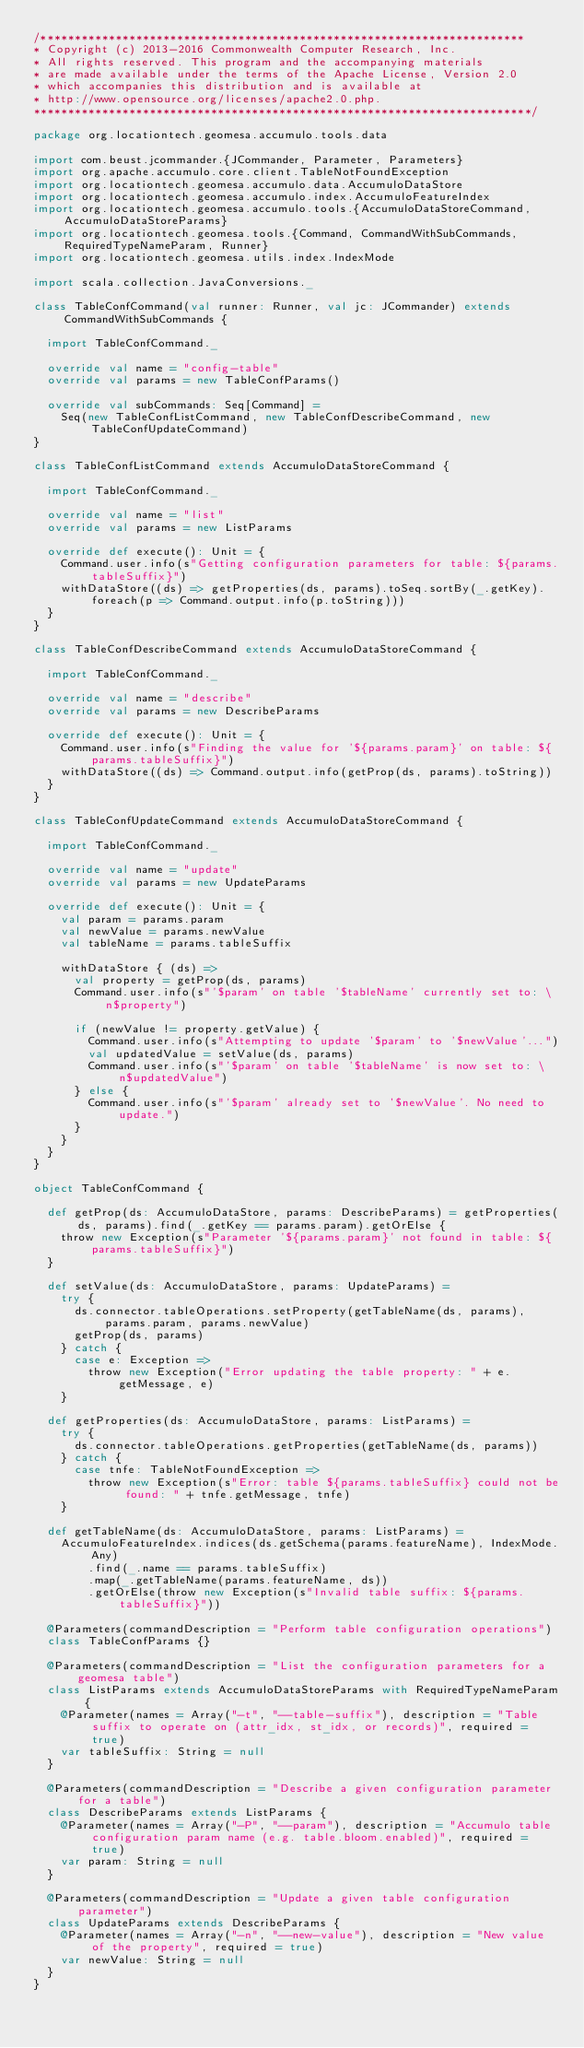<code> <loc_0><loc_0><loc_500><loc_500><_Scala_>/***********************************************************************
* Copyright (c) 2013-2016 Commonwealth Computer Research, Inc.
* All rights reserved. This program and the accompanying materials
* are made available under the terms of the Apache License, Version 2.0
* which accompanies this distribution and is available at
* http://www.opensource.org/licenses/apache2.0.php.
*************************************************************************/

package org.locationtech.geomesa.accumulo.tools.data

import com.beust.jcommander.{JCommander, Parameter, Parameters}
import org.apache.accumulo.core.client.TableNotFoundException
import org.locationtech.geomesa.accumulo.data.AccumuloDataStore
import org.locationtech.geomesa.accumulo.index.AccumuloFeatureIndex
import org.locationtech.geomesa.accumulo.tools.{AccumuloDataStoreCommand, AccumuloDataStoreParams}
import org.locationtech.geomesa.tools.{Command, CommandWithSubCommands, RequiredTypeNameParam, Runner}
import org.locationtech.geomesa.utils.index.IndexMode

import scala.collection.JavaConversions._

class TableConfCommand(val runner: Runner, val jc: JCommander) extends CommandWithSubCommands {

  import TableConfCommand._

  override val name = "config-table"
  override val params = new TableConfParams()

  override val subCommands: Seq[Command] =
    Seq(new TableConfListCommand, new TableConfDescribeCommand, new TableConfUpdateCommand)
}

class TableConfListCommand extends AccumuloDataStoreCommand {

  import TableConfCommand._

  override val name = "list"
  override val params = new ListParams

  override def execute(): Unit = {
    Command.user.info(s"Getting configuration parameters for table: ${params.tableSuffix}")
    withDataStore((ds) => getProperties(ds, params).toSeq.sortBy(_.getKey).foreach(p => Command.output.info(p.toString)))
  }
}

class TableConfDescribeCommand extends AccumuloDataStoreCommand {

  import TableConfCommand._

  override val name = "describe"
  override val params = new DescribeParams

  override def execute(): Unit = {
    Command.user.info(s"Finding the value for '${params.param}' on table: ${params.tableSuffix}")
    withDataStore((ds) => Command.output.info(getProp(ds, params).toString))
  }
}

class TableConfUpdateCommand extends AccumuloDataStoreCommand {

  import TableConfCommand._

  override val name = "update"
  override val params = new UpdateParams

  override def execute(): Unit = {
    val param = params.param
    val newValue = params.newValue
    val tableName = params.tableSuffix

    withDataStore { (ds) =>
      val property = getProp(ds, params)
      Command.user.info(s"'$param' on table '$tableName' currently set to: \n$property")

      if (newValue != property.getValue) {
        Command.user.info(s"Attempting to update '$param' to '$newValue'...")
        val updatedValue = setValue(ds, params)
        Command.user.info(s"'$param' on table '$tableName' is now set to: \n$updatedValue")
      } else {
        Command.user.info(s"'$param' already set to '$newValue'. No need to update.")
      }
    }
  }
}

object TableConfCommand {

  def getProp(ds: AccumuloDataStore, params: DescribeParams) = getProperties(ds, params).find(_.getKey == params.param).getOrElse {
    throw new Exception(s"Parameter '${params.param}' not found in table: ${params.tableSuffix}")
  }

  def setValue(ds: AccumuloDataStore, params: UpdateParams) =
    try {
      ds.connector.tableOperations.setProperty(getTableName(ds, params), params.param, params.newValue)
      getProp(ds, params)
    } catch {
      case e: Exception =>
        throw new Exception("Error updating the table property: " + e.getMessage, e)
    }

  def getProperties(ds: AccumuloDataStore, params: ListParams) =
    try {
      ds.connector.tableOperations.getProperties(getTableName(ds, params))
    } catch {
      case tnfe: TableNotFoundException =>
        throw new Exception(s"Error: table ${params.tableSuffix} could not be found: " + tnfe.getMessage, tnfe)
    }
  
  def getTableName(ds: AccumuloDataStore, params: ListParams) =
    AccumuloFeatureIndex.indices(ds.getSchema(params.featureName), IndexMode.Any)
        .find(_.name == params.tableSuffix)
        .map(_.getTableName(params.featureName, ds))
        .getOrElse(throw new Exception(s"Invalid table suffix: ${params.tableSuffix}"))
  
  @Parameters(commandDescription = "Perform table configuration operations")
  class TableConfParams {}

  @Parameters(commandDescription = "List the configuration parameters for a geomesa table")
  class ListParams extends AccumuloDataStoreParams with RequiredTypeNameParam {
    @Parameter(names = Array("-t", "--table-suffix"), description = "Table suffix to operate on (attr_idx, st_idx, or records)", required = true)
    var tableSuffix: String = null
  }

  @Parameters(commandDescription = "Describe a given configuration parameter for a table")
  class DescribeParams extends ListParams {
    @Parameter(names = Array("-P", "--param"), description = "Accumulo table configuration param name (e.g. table.bloom.enabled)", required = true)
    var param: String = null
  }

  @Parameters(commandDescription = "Update a given table configuration parameter")
  class UpdateParams extends DescribeParams {
    @Parameter(names = Array("-n", "--new-value"), description = "New value of the property", required = true)
    var newValue: String = null
  }
}
</code> 